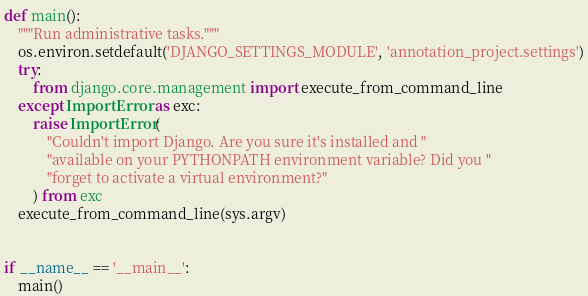Convert code to text. <code><loc_0><loc_0><loc_500><loc_500><_Python_>
def main():
    """Run administrative tasks."""
    os.environ.setdefault('DJANGO_SETTINGS_MODULE', 'annotation_project.settings')
    try:
        from django.core.management import execute_from_command_line
    except ImportError as exc:
        raise ImportError(
            "Couldn't import Django. Are you sure it's installed and "
            "available on your PYTHONPATH environment variable? Did you "
            "forget to activate a virtual environment?"
        ) from exc
    execute_from_command_line(sys.argv)


if __name__ == '__main__':
    main()
</code> 